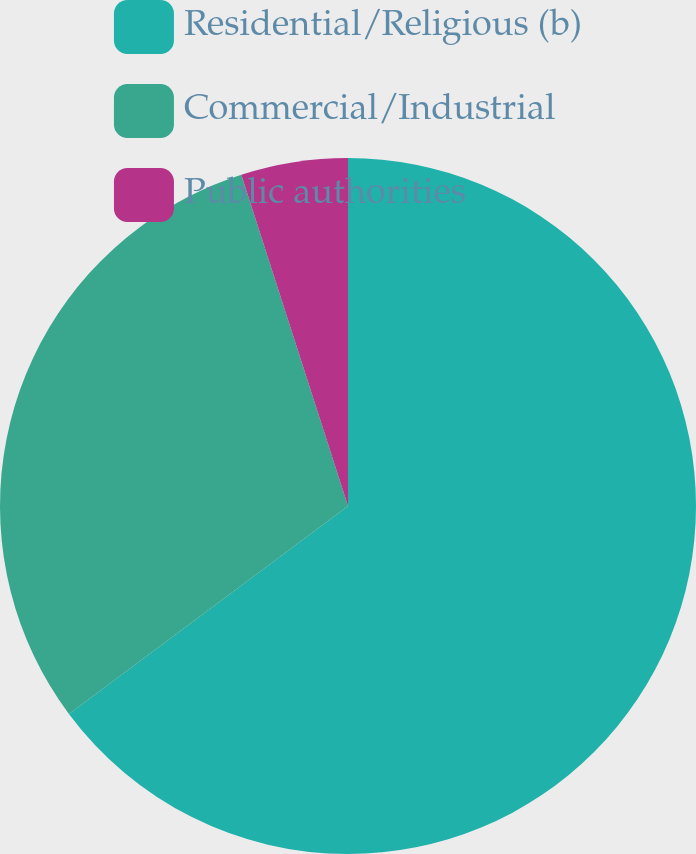Convert chart. <chart><loc_0><loc_0><loc_500><loc_500><pie_chart><fcel>Residential/Religious (b)<fcel>Commercial/Industrial<fcel>Public authorities<nl><fcel>64.81%<fcel>30.23%<fcel>4.96%<nl></chart> 